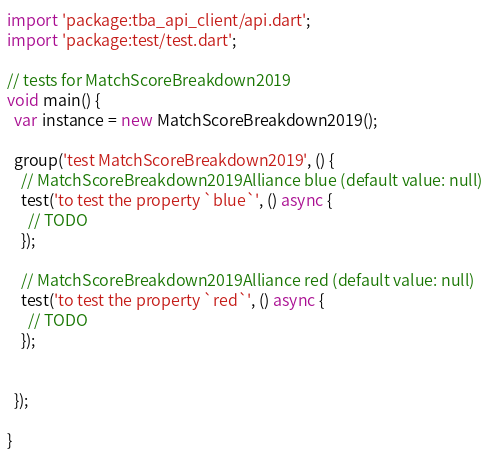Convert code to text. <code><loc_0><loc_0><loc_500><loc_500><_Dart_>import 'package:tba_api_client/api.dart';
import 'package:test/test.dart';

// tests for MatchScoreBreakdown2019
void main() {
  var instance = new MatchScoreBreakdown2019();

  group('test MatchScoreBreakdown2019', () {
    // MatchScoreBreakdown2019Alliance blue (default value: null)
    test('to test the property `blue`', () async {
      // TODO
    });

    // MatchScoreBreakdown2019Alliance red (default value: null)
    test('to test the property `red`', () async {
      // TODO
    });


  });

}
</code> 